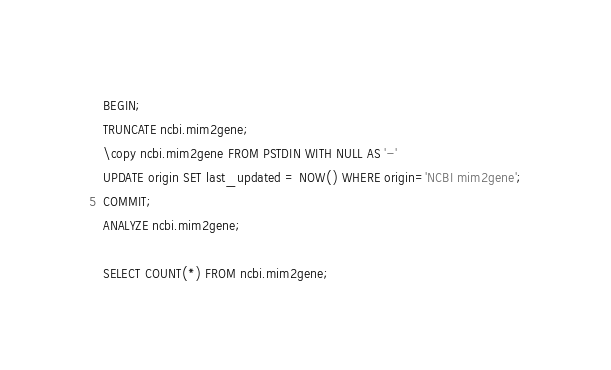Convert code to text. <code><loc_0><loc_0><loc_500><loc_500><_SQL_>BEGIN;
TRUNCATE ncbi.mim2gene;
\copy ncbi.mim2gene FROM PSTDIN WITH NULL AS '-'
UPDATE origin SET last_updated = NOW() WHERE origin='NCBI mim2gene';
COMMIT;
ANALYZE ncbi.mim2gene;

SELECT COUNT(*) FROM ncbi.mim2gene;
</code> 